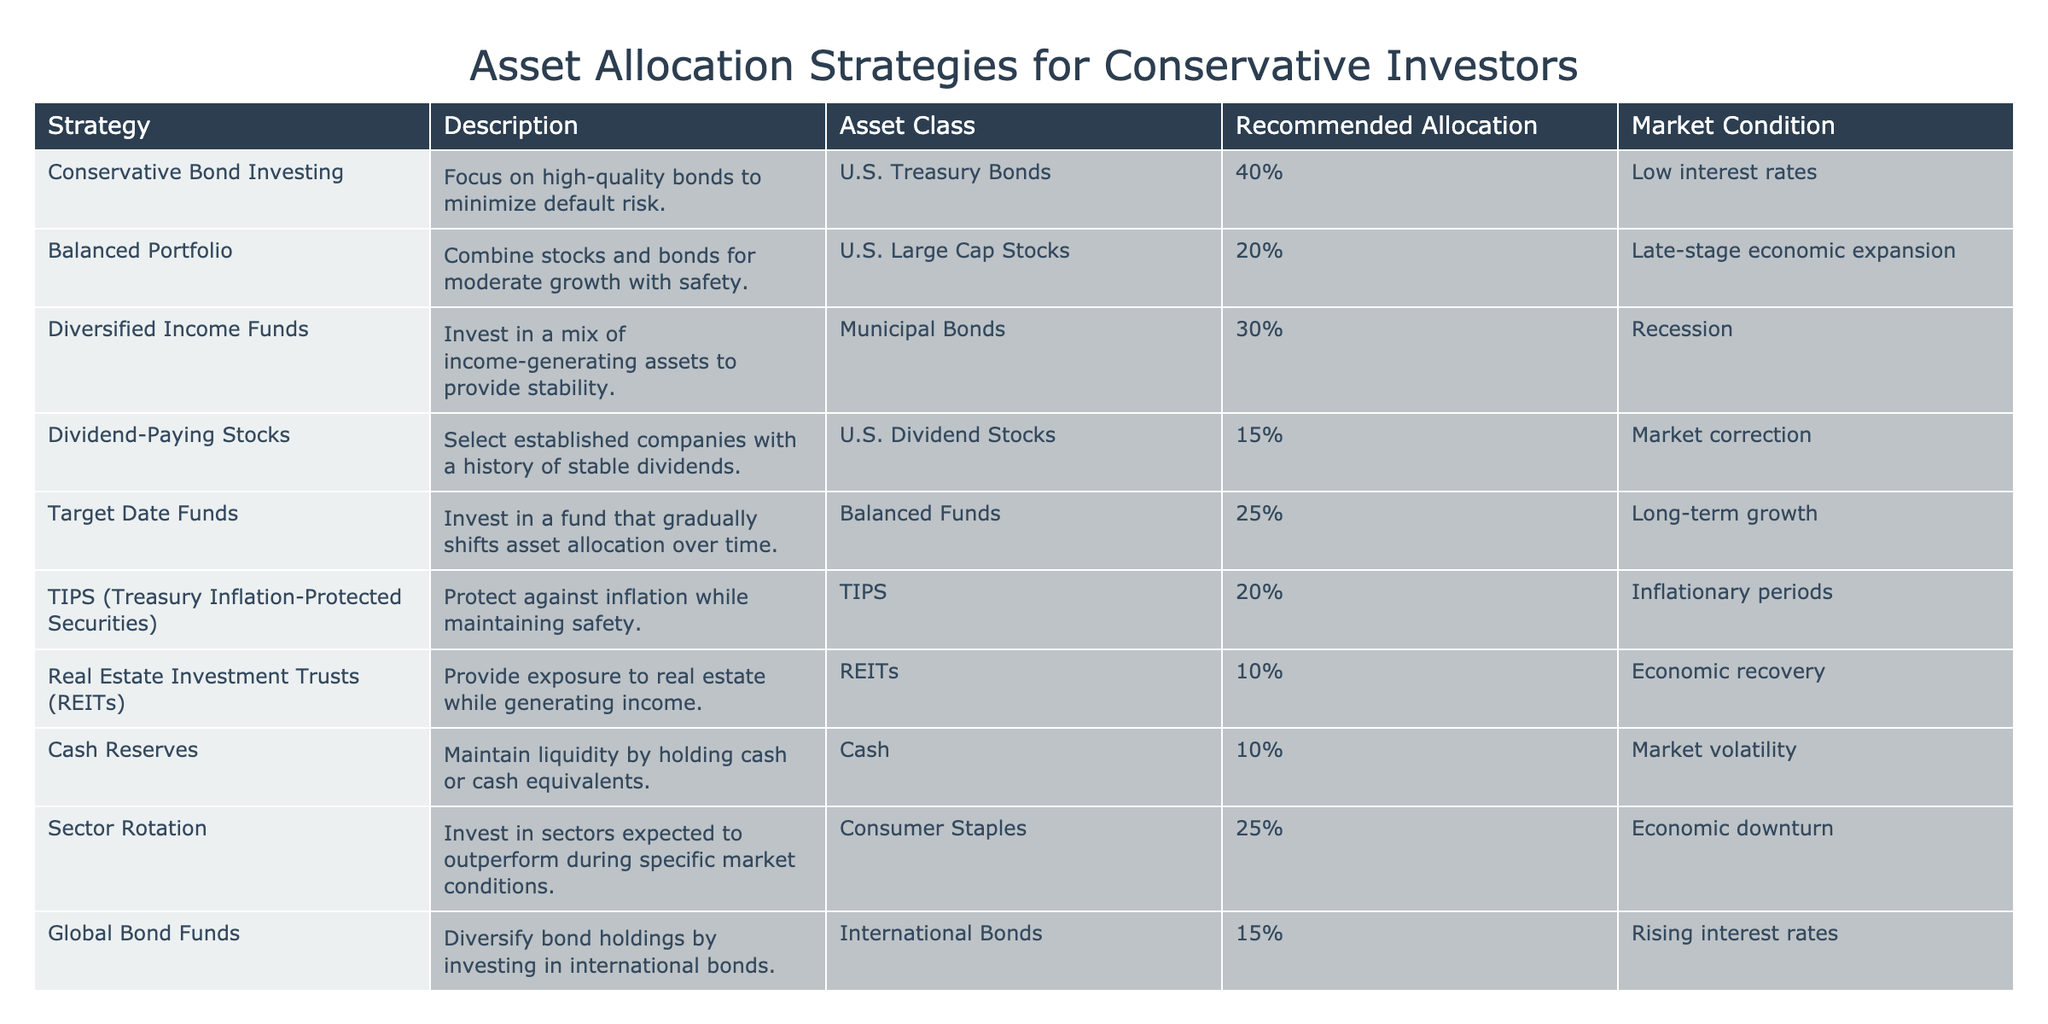What is the recommended allocation for U.S. Treasury Bonds during low interest rates? The table directly states that the recommended allocation for U.S. Treasury Bonds during low interest rates is 40%.
Answer: 40% Which strategy is focused on generating income during a recession? The table shows that the strategy for a recession is "Diversified Income Funds," which are focused on income-generating assets with a recommended allocation of 30%.
Answer: Diversified Income Funds What is the total recommended allocation for cash and REITs combined? The recommended allocation for cash is 10% and for REITs it is 10%. Therefore, the total allocation is 10% + 10% = 20%.
Answer: 20% Is it true that both TIPS and Dividend-Paying Stocks have the same recommended allocation during inflationary periods? The recommended allocation for TIPS is 20%, while Dividend-Paying Stocks do not have a specified allocation under inflationary periods. Therefore, this statement is false.
Answer: No Which asset class has the highest recommended allocation during late-stage economic expansion? According to the table, during late-stage economic expansion, U.S. Large Cap Stocks have a recommended allocation of 20%. This is the highest among the listings provided for that market condition.
Answer: U.S. Large Cap Stocks What is the average recommended allocation for cash reserves and diversified income funds? The recommended allocation for cash reserves is 10% and for diversified income funds is 30%. Adding them gives 10% + 30% = 40%. To find the average, divide by 2: 40% / 2 = 20%.
Answer: 20% What asset class should be emphasized during economic downturns? The table indicates the emphasis should be on Consumer Staples, with a recommended allocation of 25%.
Answer: Consumer Staples How does the recommended allocation for global bond funds compare to that of U.S. Treasury Bonds in rising interest rates? The recommended allocation for global bond funds is 15%, while for U.S. Treasury Bonds, it is not applicable in rising interest rates. Hence, the comparison shows that global bond funds have a 15% allocation specifically listed.
Answer: 15% for global bond funds In which market condition should investors focus on sector rotation, and what is its recommended allocation? The table specifies that sector rotation should focus on the Consumer Staples asset class with a recommended allocation of 25% during economic downturns.
Answer: Economic downturn with 25% allocation 